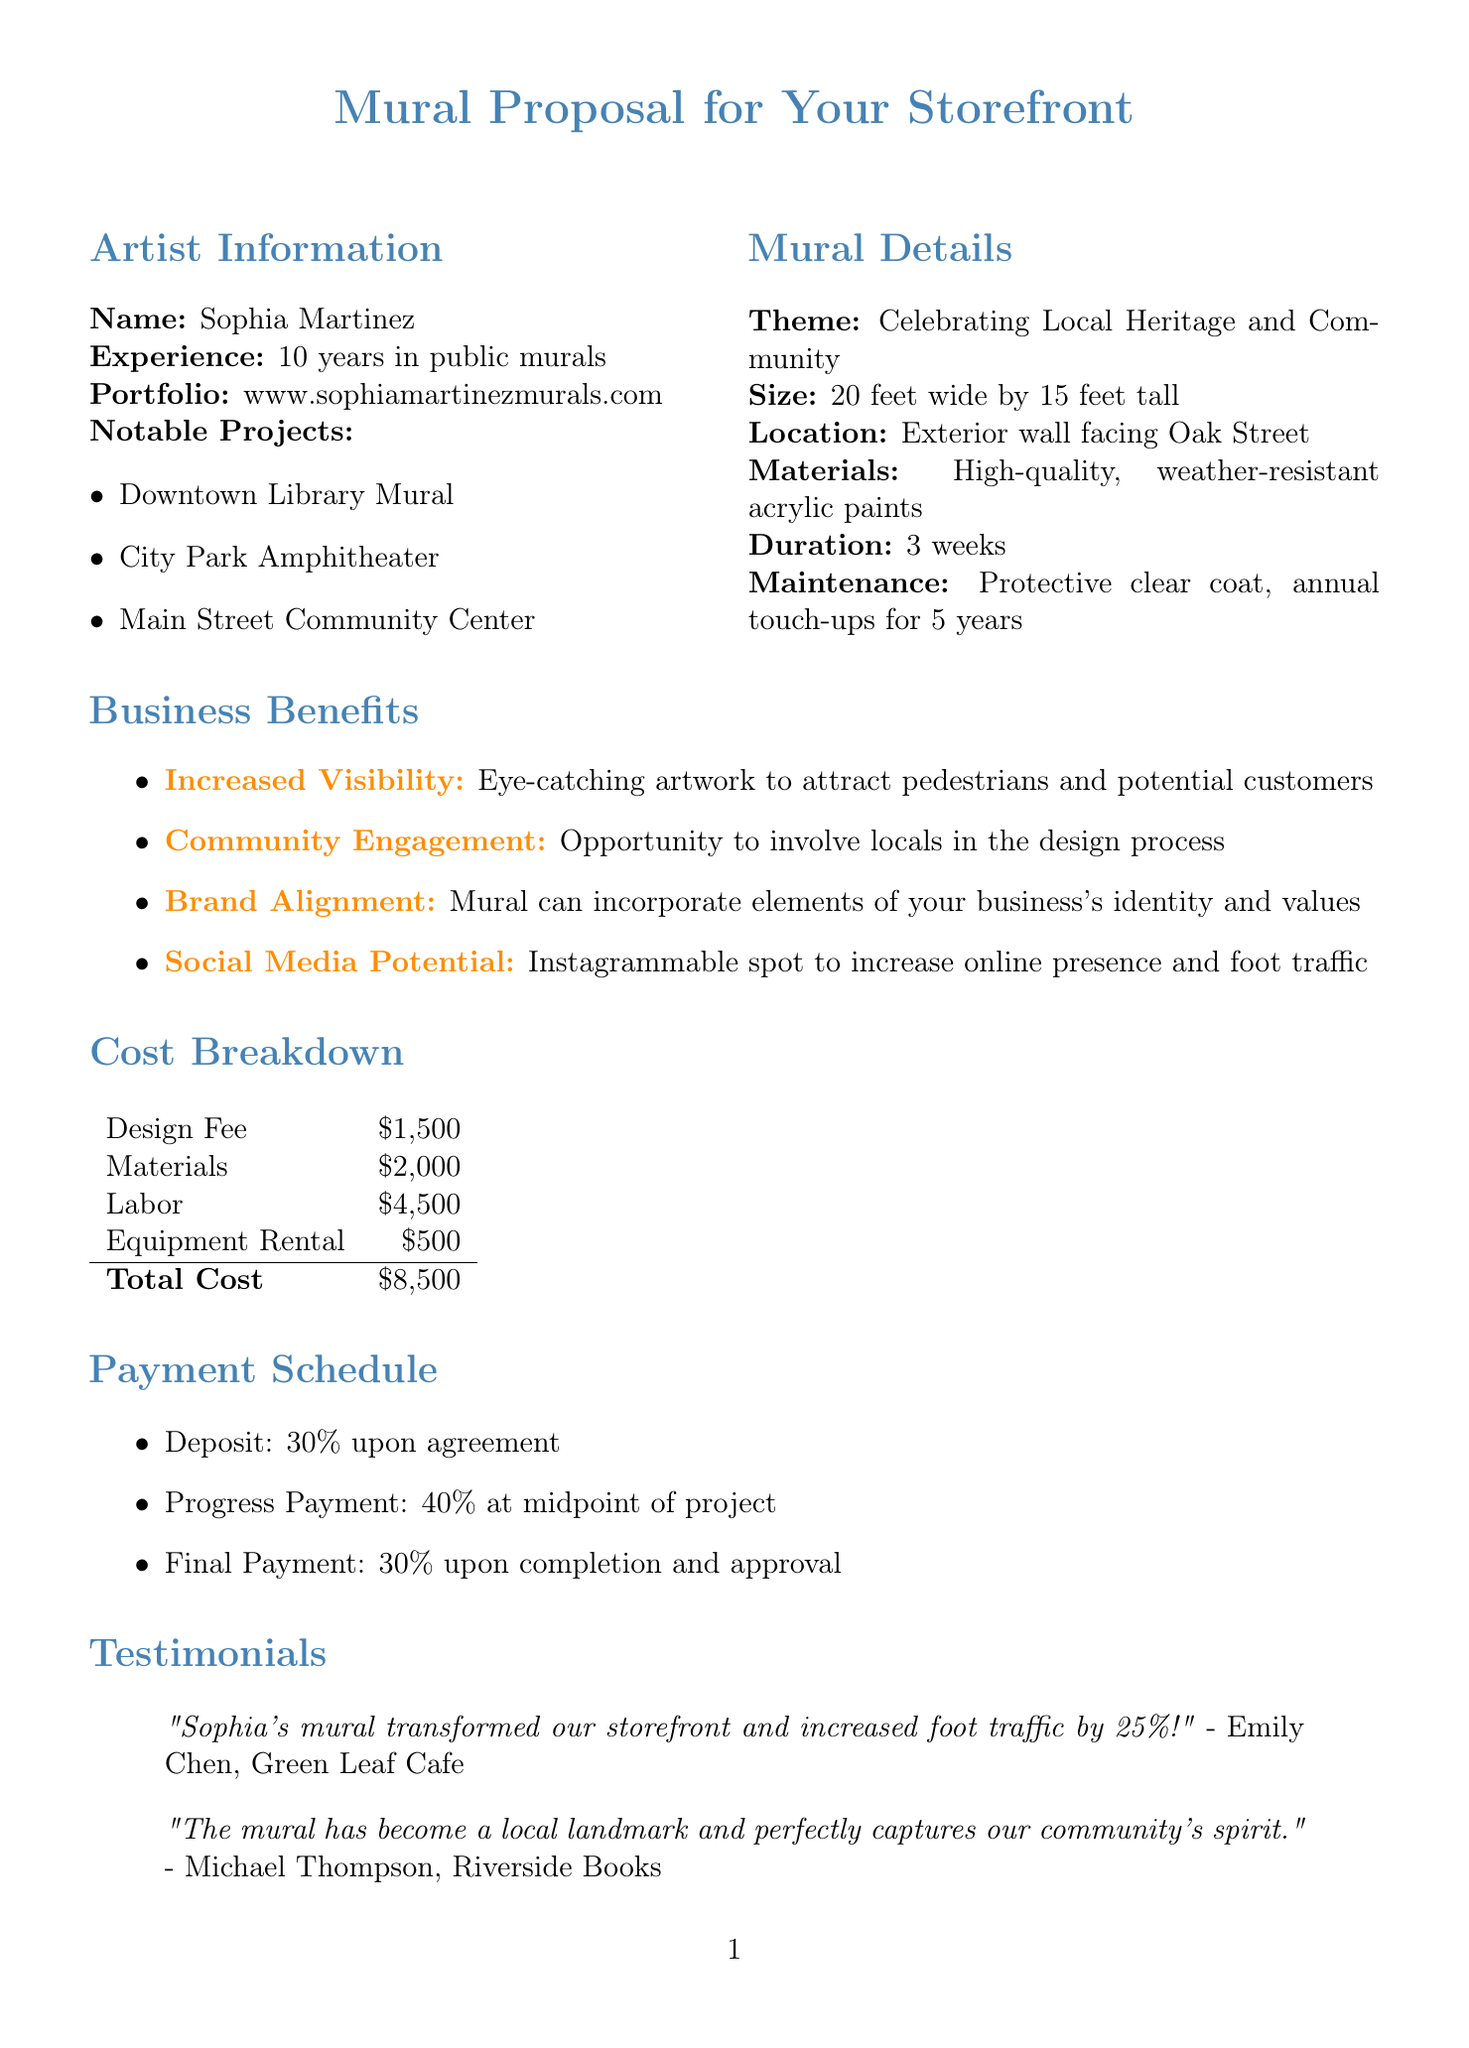What is the artist's name? The artist's name is clearly stated in the document under "Artist Information."
Answer: Sophia Martinez What is the theme of the mural? The theme is specified in the "Mural Details" section of the document.
Answer: Celebrating Local Heritage and Community How tall is the mural? The height of the mural is mentioned alongside its size in the document.
Answer: 15 feet What is the total cost of the mural? The total cost is explicitly listed in the "Cost Breakdown" section of the document.
Answer: $8,500 What percentage is the deposit upon agreement? The deposit percentage can be found in the "Payment Schedule" section of the document.
Answer: 30% What is one of the nearby attractions? Nearby attractions are listed in the "Neighborhood Context" section of the document.
Answer: Farmers market How long will the mural maintenance last? The duration of maintenance is mentioned in the "Mural Details" section.
Answer: 5 years What is included in the approval process? The process includes multiple steps outlined in the "Approval Process" section.
Answer: Design Review: 3 concept sketches provided for your selection What is an additional service offered? Additional services are listed towards the end of the document.
Answer: QR code integration linking to your business website or promotions What is a testimonial from a local business? A quote from a local business is provided in the "Testimonials" section of the document.
Answer: "Sophia's mural transformed our storefront and increased foot traffic by 25%!" - Emily Chen, Green Leaf Cafe 